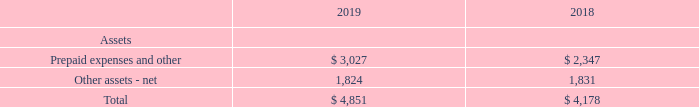Contract costs As discussed in the Significant Accounting Policies Note, Topic 606 requires the recognition of an asset for incremental costs to obtain a customer contract, which is then amortized to expense, over the respective period of expected benefit. The Partnership recognizes a contract asset for incremental commission costs paid to Verizon Wireless personnel and agents in conjunction with obtaining customer contracts.
The costs are only deferred when it is determined the commissions are incremental costs that would not have been incurred absent the customer contract and are expected to be recovered. Costs to obtain a contract are amortized and recorded ratably as commission expense over the period representing the transfer of goods or services to which the assets relate. Costs to obtain contracts are amortized over the customers' estimated device upgrade cycle of two to three years, as such costs are typically incurred each time a customer upgrades their equipment.
The amortization periods for the costs incurred to obtain a customer contract is determined at a portfolio level due to the similarities within these customer contract portfolios. Other costs, such as general costs or costs related to past performance obligations, are expensed as incurred. Deferred contract costs are classified as current or non-current within prepaid expenses and other, and other assets – net, respectively. The balances of deferred contract costs as of December 31, 2019 and 2018, included in the balance sheet were as follows:
For the years ended December 31, 2019 and 2018, the Partnership recognized expense of $3,126 and $2,161, respectively, associated with the amortization of deferred contract costs, primarily within selling, general and administrative expenses in the statements of income.
Deferred contract costs are assessed for impairment on an annual basis. An impairment charge is recognized to the extent the carrying amount of a deferred cost exceeds the remaining amount of consideration expected to be received in exchange for the goods and services related to the cost, less the expected costs related directly to providing those goods and services that have not yet been recognized as expenses. There have been no impairment charges recognized for the year ended December 31, 2019 and 2018.
What was the expense recognized by the Partnership in 2019?  $3,126. What is the Total assets for 2019? $ 4,851. What are the impairment charges in 2019? There have been no impairment charges recognized for the year ended december 31, 2019. What was the increase / (decrease) in the prepaid expenses and other assets from 2018 to 2019? 3,027 - 2,347
Answer: 680. What was the average other assets-net for 2018 and 2019? (1,824 + 1,831) / 2
Answer: 1827.5. What was the percentage increase / (decrease) in the total assets from 2018 to 2019?
Answer scale should be: percent. 4,851 / 4,178 - 1
Answer: 16.11. 